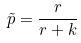<formula> <loc_0><loc_0><loc_500><loc_500>\tilde { p } = \frac { r } { r + k }</formula> 